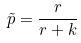<formula> <loc_0><loc_0><loc_500><loc_500>\tilde { p } = \frac { r } { r + k }</formula> 